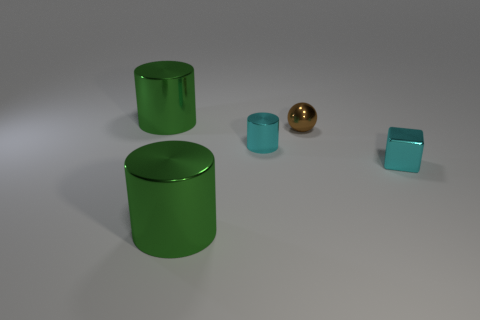Add 4 shiny things. How many objects exist? 9 Subtract all spheres. How many objects are left? 4 Add 2 brown metal things. How many brown metal things exist? 3 Subtract 0 purple cylinders. How many objects are left? 5 Subtract all tiny gray rubber spheres. Subtract all metal spheres. How many objects are left? 4 Add 5 shiny spheres. How many shiny spheres are left? 6 